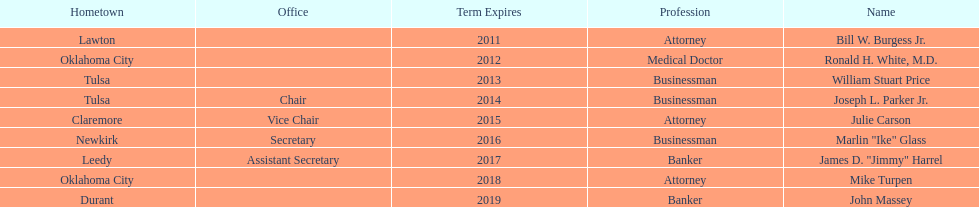Give me the full table as a dictionary. {'header': ['Hometown', 'Office', 'Term Expires', 'Profession', 'Name'], 'rows': [['Lawton', '', '2011', 'Attorney', 'Bill W. Burgess Jr.'], ['Oklahoma City', '', '2012', 'Medical Doctor', 'Ronald H. White, M.D.'], ['Tulsa', '', '2013', 'Businessman', 'William Stuart Price'], ['Tulsa', 'Chair', '2014', 'Businessman', 'Joseph L. Parker Jr.'], ['Claremore', 'Vice Chair', '2015', 'Attorney', 'Julie Carson'], ['Newkirk', 'Secretary', '2016', 'Businessman', 'Marlin "Ike" Glass'], ['Leedy', 'Assistant Secretary', '2017', 'Banker', 'James D. "Jimmy" Harrel'], ['Oklahoma City', '', '2018', 'Attorney', 'Mike Turpen'], ['Durant', '', '2019', 'Banker', 'John Massey']]} What is the cumulative quantity of current state regents involved in banking? 2. 